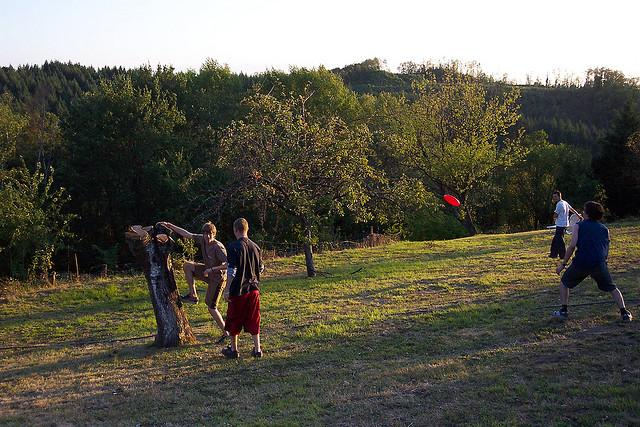Why does the boy have his leg on the tree?

Choices:
A) to wipe
B) to kick
C) to itch
D) to climb to climb 